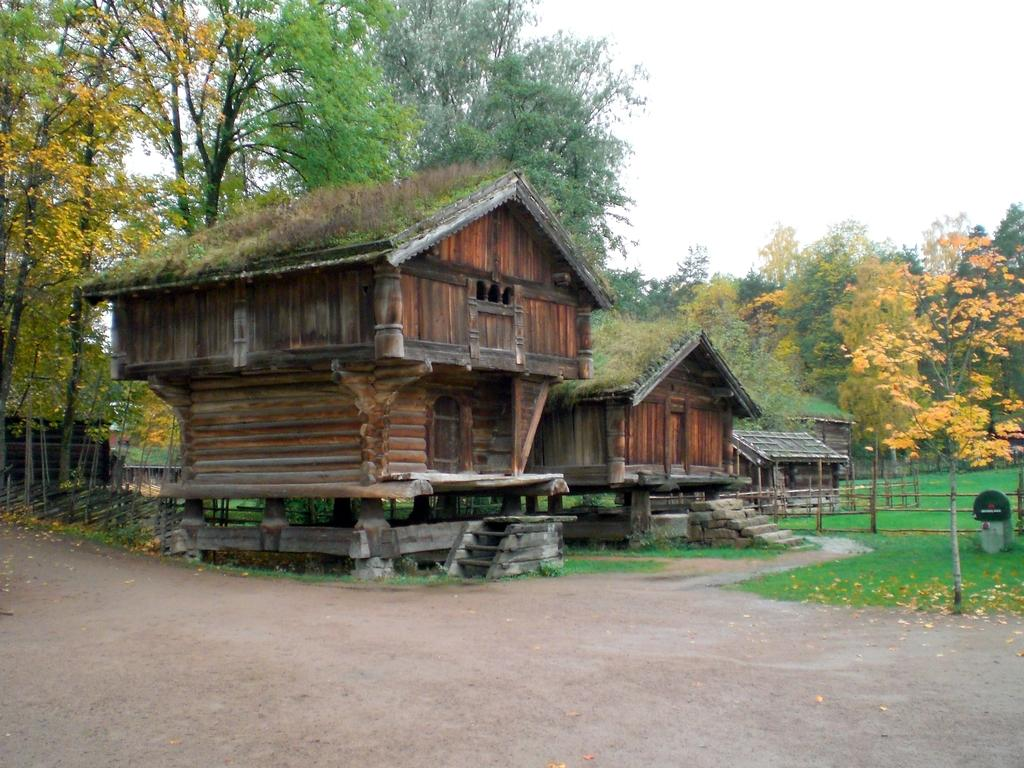What type of houses are depicted in the picture? There are wooden houses in the picture. What other natural elements can be seen in the picture? There are trees and grass in the picture. How would you describe the sky in the picture? The sky is clear in the picture. What type of leather material is used for the floor in the picture? There is no floor or leather material present in the image, as it features wooden houses, trees, grass, and a clear sky. 